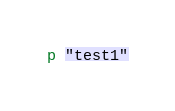Convert code to text. <code><loc_0><loc_0><loc_500><loc_500><_Ruby_>p "test1"</code> 